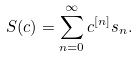Convert formula to latex. <formula><loc_0><loc_0><loc_500><loc_500>S ( { c } ) = \sum _ { n = 0 } ^ { \infty } { c } ^ { [ n ] } { s } _ { n } .</formula> 